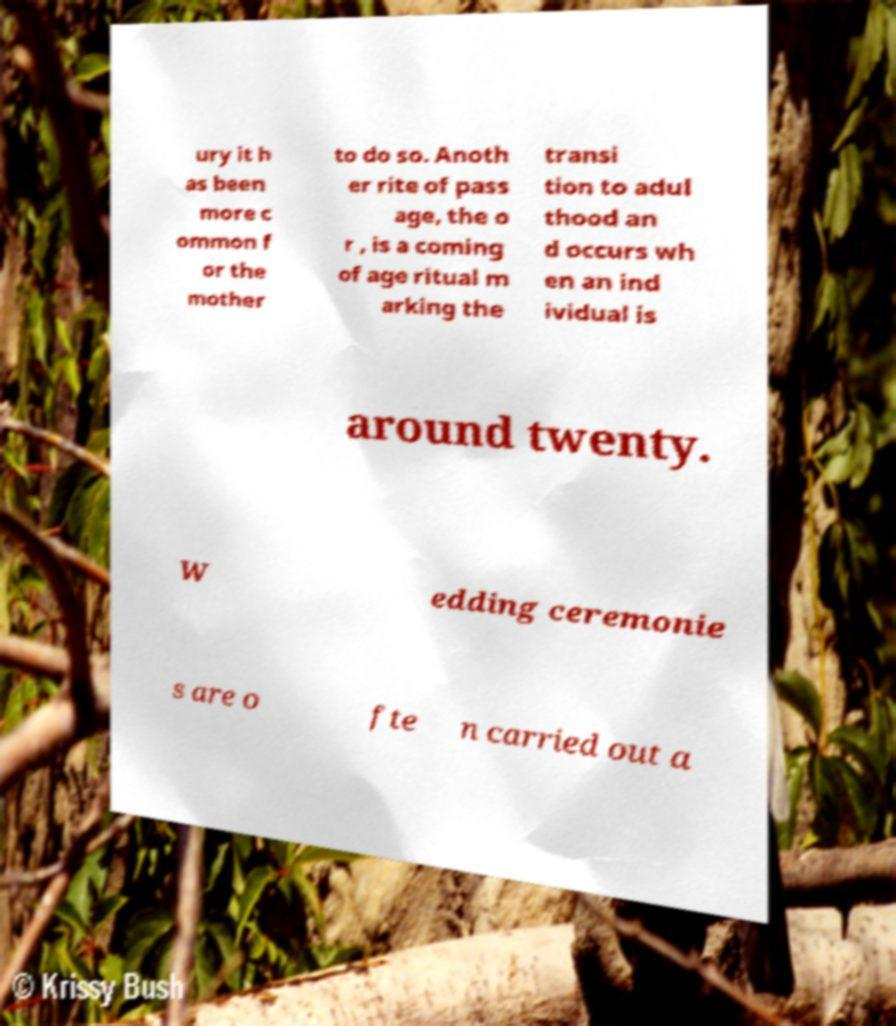Can you read and provide the text displayed in the image?This photo seems to have some interesting text. Can you extract and type it out for me? ury it h as been more c ommon f or the mother to do so. Anoth er rite of pass age, the o r , is a coming of age ritual m arking the transi tion to adul thood an d occurs wh en an ind ividual is around twenty. W edding ceremonie s are o fte n carried out a 